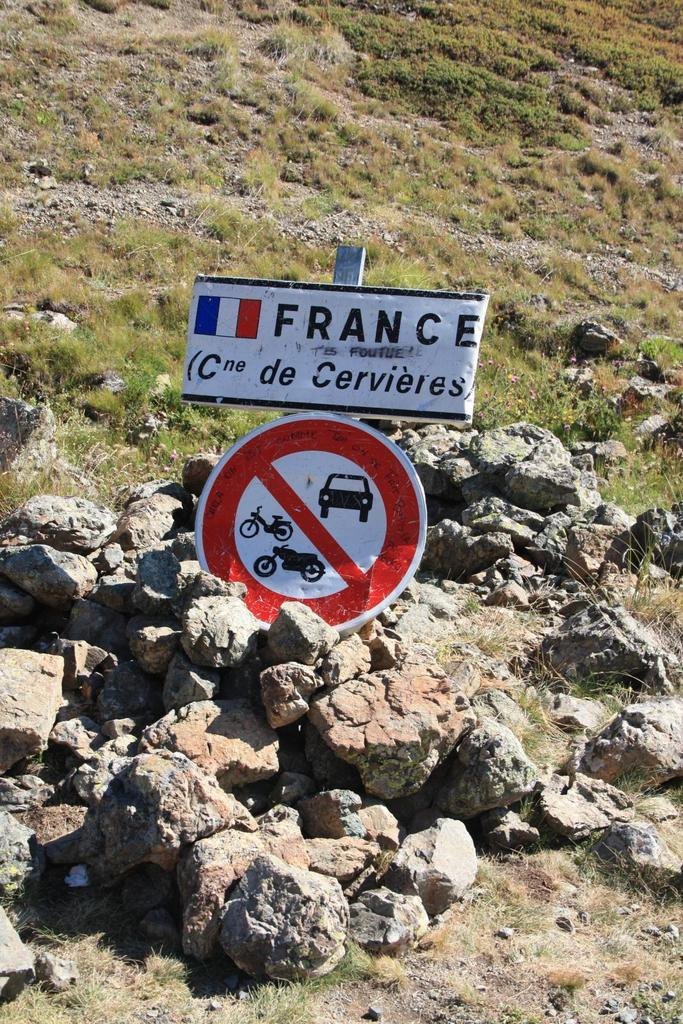<image>
Write a terse but informative summary of the picture. White sign that says France above a sign that says no drivign. 